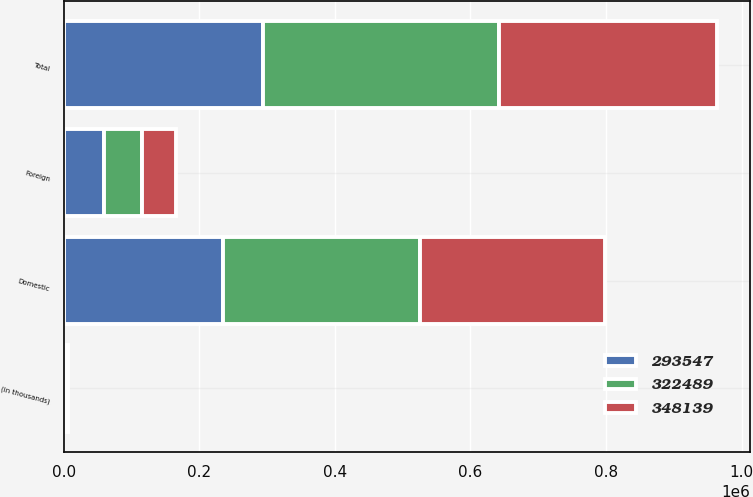<chart> <loc_0><loc_0><loc_500><loc_500><stacked_bar_chart><ecel><fcel>(in thousands)<fcel>Domestic<fcel>Foreign<fcel>Total<nl><fcel>322489<fcel>2014<fcel>291042<fcel>57097<fcel>348139<nl><fcel>348139<fcel>2013<fcel>272569<fcel>49920<fcel>322489<nl><fcel>293547<fcel>2012<fcel>234497<fcel>59050<fcel>293547<nl></chart> 